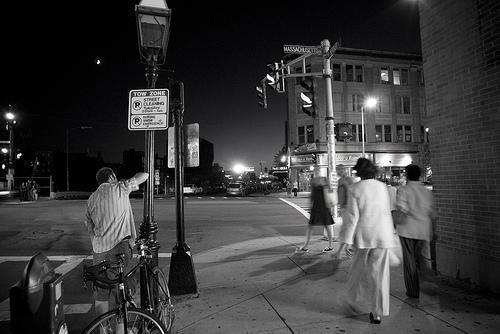How many bicycles are there?
Give a very brief answer. 1. 